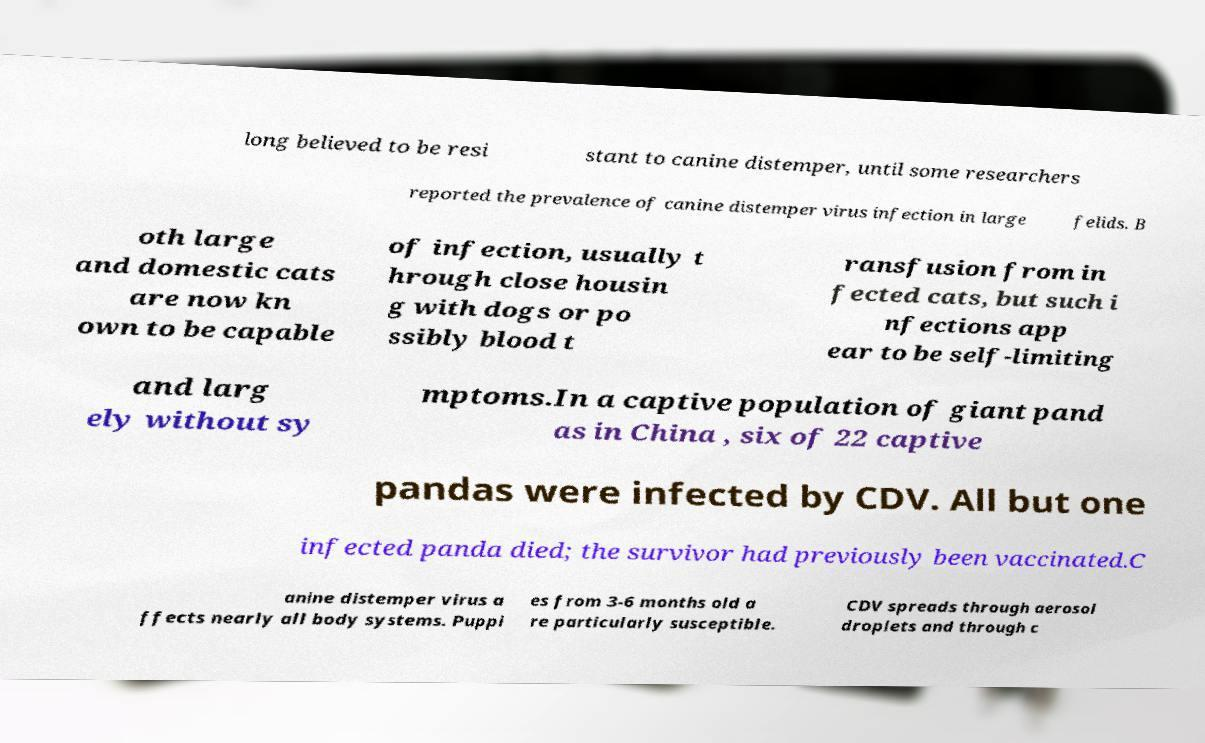What messages or text are displayed in this image? I need them in a readable, typed format. long believed to be resi stant to canine distemper, until some researchers reported the prevalence of canine distemper virus infection in large felids. B oth large and domestic cats are now kn own to be capable of infection, usually t hrough close housin g with dogs or po ssibly blood t ransfusion from in fected cats, but such i nfections app ear to be self-limiting and larg ely without sy mptoms.In a captive population of giant pand as in China , six of 22 captive pandas were infected by CDV. All but one infected panda died; the survivor had previously been vaccinated.C anine distemper virus a ffects nearly all body systems. Puppi es from 3-6 months old a re particularly susceptible. CDV spreads through aerosol droplets and through c 